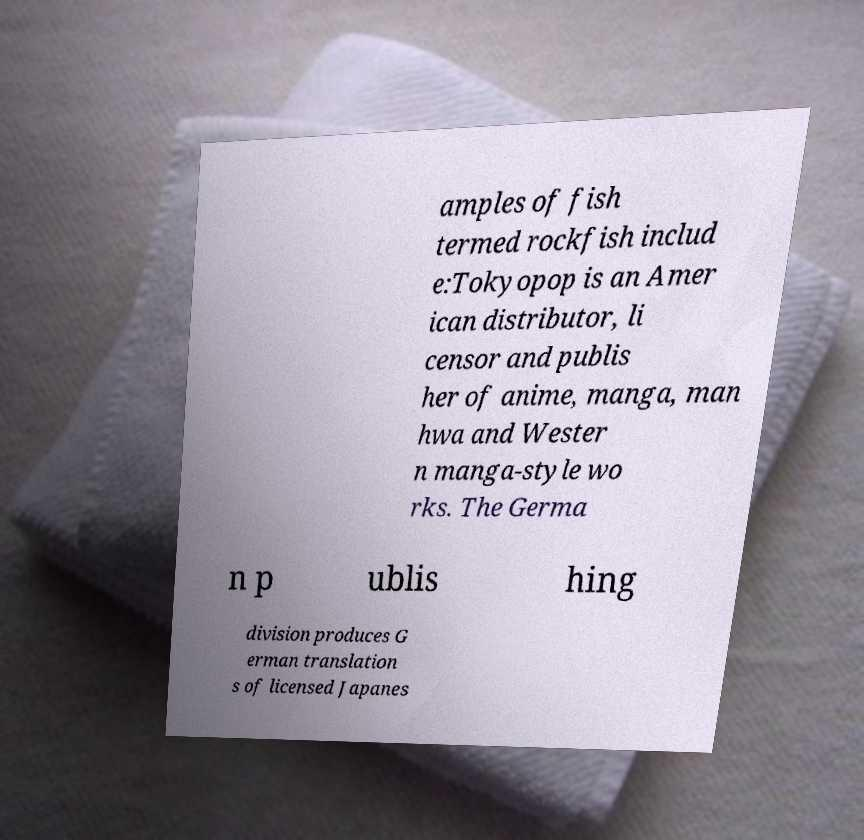For documentation purposes, I need the text within this image transcribed. Could you provide that? amples of fish termed rockfish includ e:Tokyopop is an Amer ican distributor, li censor and publis her of anime, manga, man hwa and Wester n manga-style wo rks. The Germa n p ublis hing division produces G erman translation s of licensed Japanes 